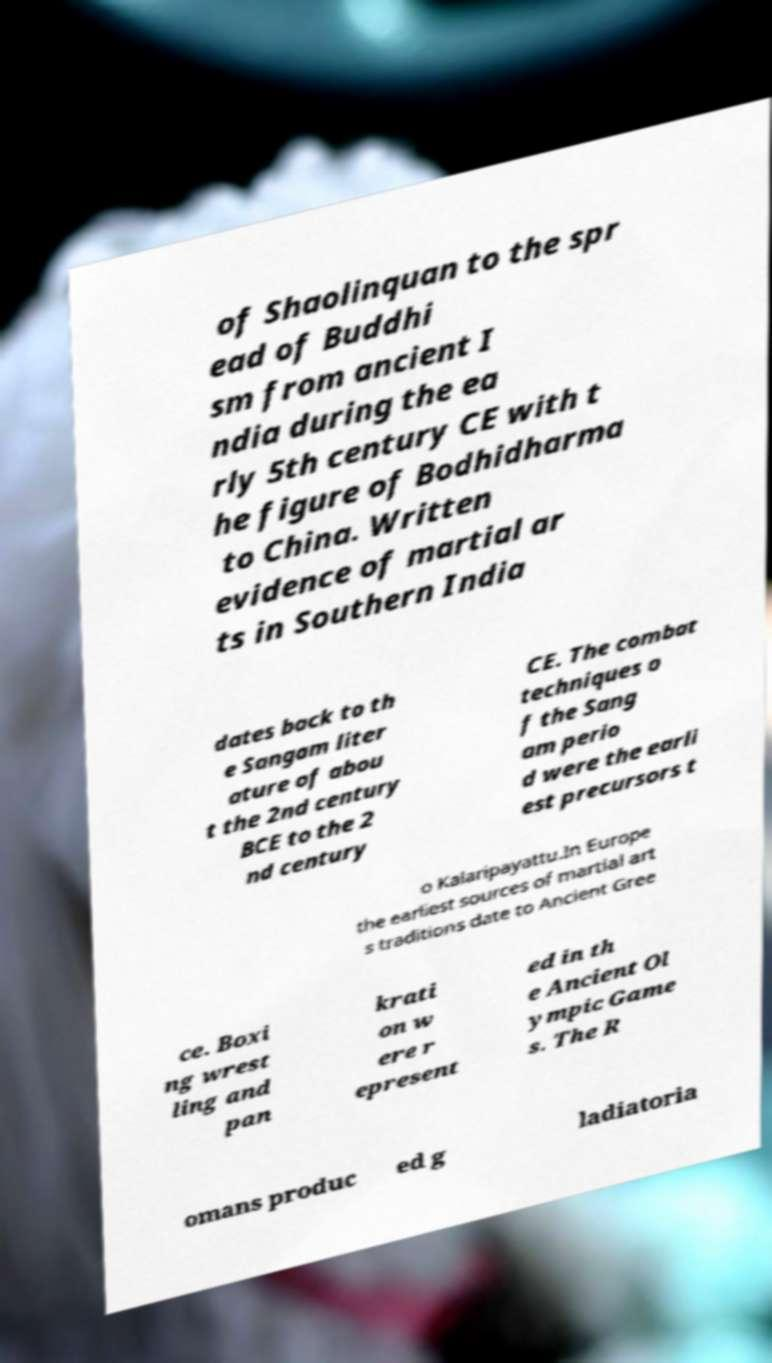For documentation purposes, I need the text within this image transcribed. Could you provide that? of Shaolinquan to the spr ead of Buddhi sm from ancient I ndia during the ea rly 5th century CE with t he figure of Bodhidharma to China. Written evidence of martial ar ts in Southern India dates back to th e Sangam liter ature of abou t the 2nd century BCE to the 2 nd century CE. The combat techniques o f the Sang am perio d were the earli est precursors t o Kalaripayattu.In Europe the earliest sources of martial art s traditions date to Ancient Gree ce. Boxi ng wrest ling and pan krati on w ere r epresent ed in th e Ancient Ol ympic Game s. The R omans produc ed g ladiatoria 